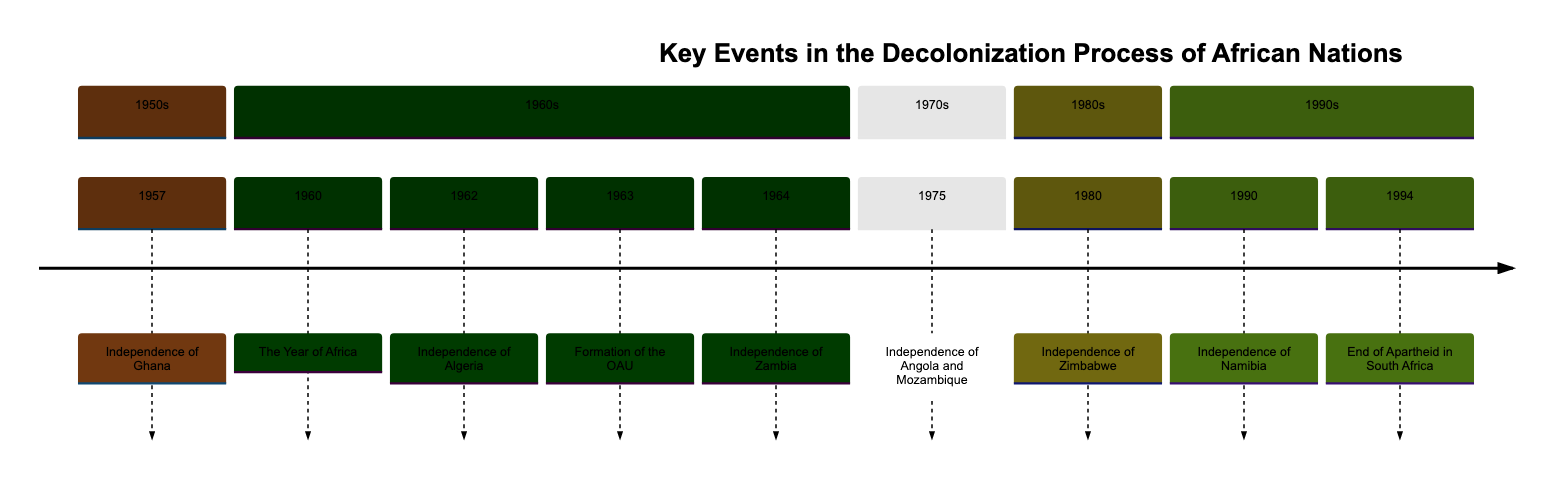What year did Ghana gain independence? According to the timeline, Ghana gained independence in the year 1957, which is listed as the first event in the document.
Answer: 1957 Which country gained independence on July 3, 1962? The timeline specifies that Algeria gained independence on July 3, 1962, which is indicated in the entry for that year.
Answer: Algeria What significant event is marked in 1960? The timeline states that 1960 is titled "The Year of Africa," during which seventeen African countries declared independence, making it a significant year in the decolonization process.
Answer: The Year of Africa Who was the first President of Zambia? The details for the independence of Zambia in 1964 indicate that Kenneth Kaunda became its first President after gaining independence from the United Kingdom.
Answer: Kenneth Kaunda Which two countries gained independence in 1975? The timeline entry for the year 1975 mentions that both Angola and Mozambique gained independence from Portuguese colonial rule.
Answer: Angola and Mozambique When did Namibia gain independence? The timeline lists Namibia's independence date as March 21, 1990, which is provided within the description of that event.
Answer: March 21, 1990 How many countries declared independence in 1960? The timeline specifies that seventeen African countries declared independence in 1960, making it a landmark year for decolonization.
Answer: Seventeen What movement started in 1963? In 1963, the timeline notes the formation of the Organization of African Unity (OAU), which aimed at promoting solidarity between African nations and eliminating colonialism in Africa.
Answer: Formation of the Organization of African Unity (OAU) What event occurred in South Africa in 1994? The timeline specifies that in 1994, Nelson Mandela was elected President during the first multiracial elections, marking the end of apartheid rule in South Africa.
Answer: End of Apartheid in South Africa 